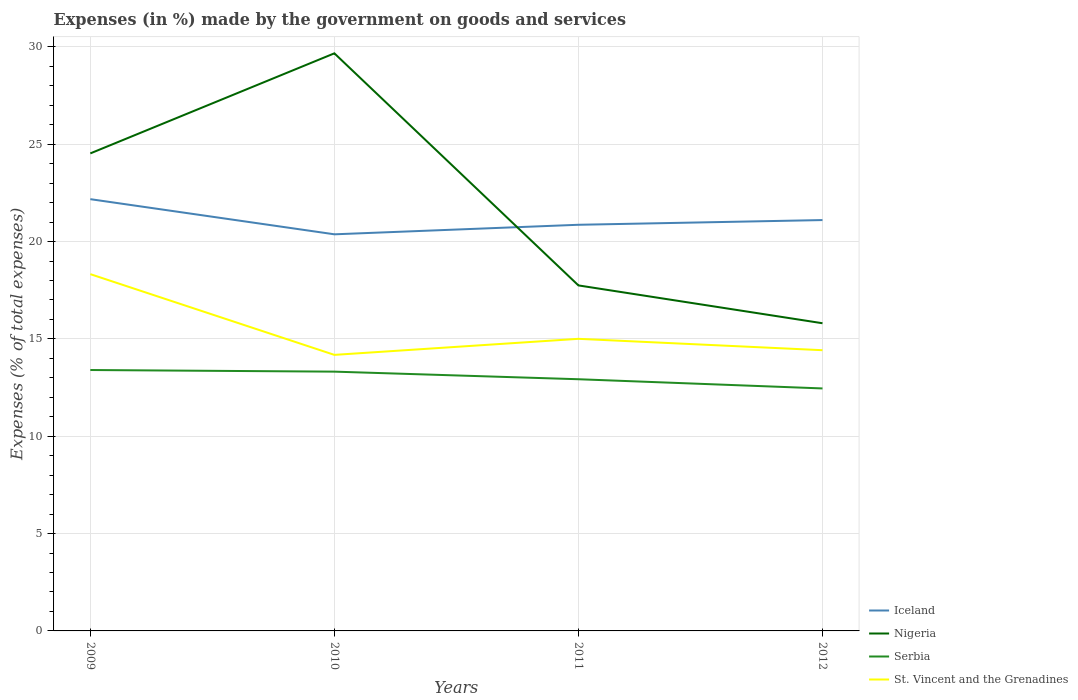Does the line corresponding to St. Vincent and the Grenadines intersect with the line corresponding to Iceland?
Provide a short and direct response. No. Is the number of lines equal to the number of legend labels?
Your answer should be compact. Yes. Across all years, what is the maximum percentage of expenses made by the government on goods and services in Nigeria?
Offer a terse response. 15.8. In which year was the percentage of expenses made by the government on goods and services in Serbia maximum?
Provide a succinct answer. 2012. What is the total percentage of expenses made by the government on goods and services in Nigeria in the graph?
Keep it short and to the point. 8.72. What is the difference between the highest and the second highest percentage of expenses made by the government on goods and services in Serbia?
Your answer should be compact. 0.95. Is the percentage of expenses made by the government on goods and services in St. Vincent and the Grenadines strictly greater than the percentage of expenses made by the government on goods and services in Iceland over the years?
Ensure brevity in your answer.  Yes. How many lines are there?
Your answer should be very brief. 4. How many years are there in the graph?
Ensure brevity in your answer.  4. Does the graph contain any zero values?
Make the answer very short. No. Does the graph contain grids?
Offer a very short reply. Yes. How many legend labels are there?
Provide a short and direct response. 4. What is the title of the graph?
Your response must be concise. Expenses (in %) made by the government on goods and services. What is the label or title of the Y-axis?
Offer a terse response. Expenses (% of total expenses). What is the Expenses (% of total expenses) of Iceland in 2009?
Ensure brevity in your answer.  22.18. What is the Expenses (% of total expenses) in Nigeria in 2009?
Ensure brevity in your answer.  24.53. What is the Expenses (% of total expenses) in Serbia in 2009?
Make the answer very short. 13.4. What is the Expenses (% of total expenses) of St. Vincent and the Grenadines in 2009?
Provide a short and direct response. 18.33. What is the Expenses (% of total expenses) of Iceland in 2010?
Give a very brief answer. 20.37. What is the Expenses (% of total expenses) in Nigeria in 2010?
Keep it short and to the point. 29.67. What is the Expenses (% of total expenses) in Serbia in 2010?
Your answer should be compact. 13.32. What is the Expenses (% of total expenses) in St. Vincent and the Grenadines in 2010?
Make the answer very short. 14.18. What is the Expenses (% of total expenses) of Iceland in 2011?
Ensure brevity in your answer.  20.86. What is the Expenses (% of total expenses) in Nigeria in 2011?
Give a very brief answer. 17.75. What is the Expenses (% of total expenses) of Serbia in 2011?
Ensure brevity in your answer.  12.93. What is the Expenses (% of total expenses) of St. Vincent and the Grenadines in 2011?
Ensure brevity in your answer.  15. What is the Expenses (% of total expenses) of Iceland in 2012?
Ensure brevity in your answer.  21.11. What is the Expenses (% of total expenses) of Nigeria in 2012?
Provide a succinct answer. 15.8. What is the Expenses (% of total expenses) of Serbia in 2012?
Offer a terse response. 12.46. What is the Expenses (% of total expenses) of St. Vincent and the Grenadines in 2012?
Give a very brief answer. 14.42. Across all years, what is the maximum Expenses (% of total expenses) of Iceland?
Offer a very short reply. 22.18. Across all years, what is the maximum Expenses (% of total expenses) in Nigeria?
Make the answer very short. 29.67. Across all years, what is the maximum Expenses (% of total expenses) in Serbia?
Your answer should be compact. 13.4. Across all years, what is the maximum Expenses (% of total expenses) of St. Vincent and the Grenadines?
Offer a terse response. 18.33. Across all years, what is the minimum Expenses (% of total expenses) of Iceland?
Your answer should be compact. 20.37. Across all years, what is the minimum Expenses (% of total expenses) of Nigeria?
Your response must be concise. 15.8. Across all years, what is the minimum Expenses (% of total expenses) of Serbia?
Ensure brevity in your answer.  12.46. Across all years, what is the minimum Expenses (% of total expenses) of St. Vincent and the Grenadines?
Your answer should be compact. 14.18. What is the total Expenses (% of total expenses) in Iceland in the graph?
Your response must be concise. 84.52. What is the total Expenses (% of total expenses) of Nigeria in the graph?
Offer a terse response. 87.75. What is the total Expenses (% of total expenses) in Serbia in the graph?
Offer a terse response. 52.1. What is the total Expenses (% of total expenses) in St. Vincent and the Grenadines in the graph?
Your answer should be very brief. 61.93. What is the difference between the Expenses (% of total expenses) of Iceland in 2009 and that in 2010?
Keep it short and to the point. 1.8. What is the difference between the Expenses (% of total expenses) of Nigeria in 2009 and that in 2010?
Give a very brief answer. -5.14. What is the difference between the Expenses (% of total expenses) in Serbia in 2009 and that in 2010?
Provide a succinct answer. 0.08. What is the difference between the Expenses (% of total expenses) of St. Vincent and the Grenadines in 2009 and that in 2010?
Offer a very short reply. 4.15. What is the difference between the Expenses (% of total expenses) in Iceland in 2009 and that in 2011?
Offer a very short reply. 1.32. What is the difference between the Expenses (% of total expenses) in Nigeria in 2009 and that in 2011?
Provide a succinct answer. 6.78. What is the difference between the Expenses (% of total expenses) of Serbia in 2009 and that in 2011?
Your answer should be very brief. 0.47. What is the difference between the Expenses (% of total expenses) of St. Vincent and the Grenadines in 2009 and that in 2011?
Offer a terse response. 3.32. What is the difference between the Expenses (% of total expenses) in Iceland in 2009 and that in 2012?
Make the answer very short. 1.07. What is the difference between the Expenses (% of total expenses) in Nigeria in 2009 and that in 2012?
Give a very brief answer. 8.72. What is the difference between the Expenses (% of total expenses) in Serbia in 2009 and that in 2012?
Provide a succinct answer. 0.95. What is the difference between the Expenses (% of total expenses) in St. Vincent and the Grenadines in 2009 and that in 2012?
Ensure brevity in your answer.  3.91. What is the difference between the Expenses (% of total expenses) in Iceland in 2010 and that in 2011?
Ensure brevity in your answer.  -0.49. What is the difference between the Expenses (% of total expenses) of Nigeria in 2010 and that in 2011?
Make the answer very short. 11.92. What is the difference between the Expenses (% of total expenses) in Serbia in 2010 and that in 2011?
Provide a succinct answer. 0.39. What is the difference between the Expenses (% of total expenses) of St. Vincent and the Grenadines in 2010 and that in 2011?
Ensure brevity in your answer.  -0.82. What is the difference between the Expenses (% of total expenses) in Iceland in 2010 and that in 2012?
Offer a very short reply. -0.73. What is the difference between the Expenses (% of total expenses) of Nigeria in 2010 and that in 2012?
Your response must be concise. 13.86. What is the difference between the Expenses (% of total expenses) in Serbia in 2010 and that in 2012?
Your response must be concise. 0.86. What is the difference between the Expenses (% of total expenses) of St. Vincent and the Grenadines in 2010 and that in 2012?
Keep it short and to the point. -0.24. What is the difference between the Expenses (% of total expenses) of Iceland in 2011 and that in 2012?
Give a very brief answer. -0.24. What is the difference between the Expenses (% of total expenses) of Nigeria in 2011 and that in 2012?
Provide a succinct answer. 1.94. What is the difference between the Expenses (% of total expenses) in Serbia in 2011 and that in 2012?
Give a very brief answer. 0.47. What is the difference between the Expenses (% of total expenses) in St. Vincent and the Grenadines in 2011 and that in 2012?
Your answer should be compact. 0.58. What is the difference between the Expenses (% of total expenses) of Iceland in 2009 and the Expenses (% of total expenses) of Nigeria in 2010?
Ensure brevity in your answer.  -7.49. What is the difference between the Expenses (% of total expenses) in Iceland in 2009 and the Expenses (% of total expenses) in Serbia in 2010?
Your answer should be very brief. 8.86. What is the difference between the Expenses (% of total expenses) in Iceland in 2009 and the Expenses (% of total expenses) in St. Vincent and the Grenadines in 2010?
Give a very brief answer. 8. What is the difference between the Expenses (% of total expenses) in Nigeria in 2009 and the Expenses (% of total expenses) in Serbia in 2010?
Offer a terse response. 11.21. What is the difference between the Expenses (% of total expenses) of Nigeria in 2009 and the Expenses (% of total expenses) of St. Vincent and the Grenadines in 2010?
Ensure brevity in your answer.  10.35. What is the difference between the Expenses (% of total expenses) of Serbia in 2009 and the Expenses (% of total expenses) of St. Vincent and the Grenadines in 2010?
Your answer should be compact. -0.78. What is the difference between the Expenses (% of total expenses) of Iceland in 2009 and the Expenses (% of total expenses) of Nigeria in 2011?
Your answer should be compact. 4.43. What is the difference between the Expenses (% of total expenses) of Iceland in 2009 and the Expenses (% of total expenses) of Serbia in 2011?
Your response must be concise. 9.25. What is the difference between the Expenses (% of total expenses) in Iceland in 2009 and the Expenses (% of total expenses) in St. Vincent and the Grenadines in 2011?
Give a very brief answer. 7.17. What is the difference between the Expenses (% of total expenses) in Nigeria in 2009 and the Expenses (% of total expenses) in Serbia in 2011?
Offer a terse response. 11.6. What is the difference between the Expenses (% of total expenses) of Nigeria in 2009 and the Expenses (% of total expenses) of St. Vincent and the Grenadines in 2011?
Provide a short and direct response. 9.53. What is the difference between the Expenses (% of total expenses) in Serbia in 2009 and the Expenses (% of total expenses) in St. Vincent and the Grenadines in 2011?
Provide a short and direct response. -1.6. What is the difference between the Expenses (% of total expenses) in Iceland in 2009 and the Expenses (% of total expenses) in Nigeria in 2012?
Your response must be concise. 6.37. What is the difference between the Expenses (% of total expenses) of Iceland in 2009 and the Expenses (% of total expenses) of Serbia in 2012?
Provide a short and direct response. 9.72. What is the difference between the Expenses (% of total expenses) of Iceland in 2009 and the Expenses (% of total expenses) of St. Vincent and the Grenadines in 2012?
Make the answer very short. 7.76. What is the difference between the Expenses (% of total expenses) in Nigeria in 2009 and the Expenses (% of total expenses) in Serbia in 2012?
Provide a succinct answer. 12.07. What is the difference between the Expenses (% of total expenses) of Nigeria in 2009 and the Expenses (% of total expenses) of St. Vincent and the Grenadines in 2012?
Offer a terse response. 10.11. What is the difference between the Expenses (% of total expenses) in Serbia in 2009 and the Expenses (% of total expenses) in St. Vincent and the Grenadines in 2012?
Ensure brevity in your answer.  -1.02. What is the difference between the Expenses (% of total expenses) of Iceland in 2010 and the Expenses (% of total expenses) of Nigeria in 2011?
Your answer should be very brief. 2.63. What is the difference between the Expenses (% of total expenses) in Iceland in 2010 and the Expenses (% of total expenses) in Serbia in 2011?
Your answer should be very brief. 7.44. What is the difference between the Expenses (% of total expenses) in Iceland in 2010 and the Expenses (% of total expenses) in St. Vincent and the Grenadines in 2011?
Keep it short and to the point. 5.37. What is the difference between the Expenses (% of total expenses) in Nigeria in 2010 and the Expenses (% of total expenses) in Serbia in 2011?
Ensure brevity in your answer.  16.74. What is the difference between the Expenses (% of total expenses) in Nigeria in 2010 and the Expenses (% of total expenses) in St. Vincent and the Grenadines in 2011?
Make the answer very short. 14.67. What is the difference between the Expenses (% of total expenses) in Serbia in 2010 and the Expenses (% of total expenses) in St. Vincent and the Grenadines in 2011?
Your answer should be compact. -1.69. What is the difference between the Expenses (% of total expenses) in Iceland in 2010 and the Expenses (% of total expenses) in Nigeria in 2012?
Offer a terse response. 4.57. What is the difference between the Expenses (% of total expenses) in Iceland in 2010 and the Expenses (% of total expenses) in Serbia in 2012?
Keep it short and to the point. 7.92. What is the difference between the Expenses (% of total expenses) in Iceland in 2010 and the Expenses (% of total expenses) in St. Vincent and the Grenadines in 2012?
Keep it short and to the point. 5.95. What is the difference between the Expenses (% of total expenses) of Nigeria in 2010 and the Expenses (% of total expenses) of Serbia in 2012?
Give a very brief answer. 17.21. What is the difference between the Expenses (% of total expenses) in Nigeria in 2010 and the Expenses (% of total expenses) in St. Vincent and the Grenadines in 2012?
Your answer should be compact. 15.25. What is the difference between the Expenses (% of total expenses) in Serbia in 2010 and the Expenses (% of total expenses) in St. Vincent and the Grenadines in 2012?
Offer a very short reply. -1.1. What is the difference between the Expenses (% of total expenses) in Iceland in 2011 and the Expenses (% of total expenses) in Nigeria in 2012?
Offer a terse response. 5.06. What is the difference between the Expenses (% of total expenses) of Iceland in 2011 and the Expenses (% of total expenses) of Serbia in 2012?
Provide a short and direct response. 8.41. What is the difference between the Expenses (% of total expenses) of Iceland in 2011 and the Expenses (% of total expenses) of St. Vincent and the Grenadines in 2012?
Give a very brief answer. 6.44. What is the difference between the Expenses (% of total expenses) of Nigeria in 2011 and the Expenses (% of total expenses) of Serbia in 2012?
Your response must be concise. 5.29. What is the difference between the Expenses (% of total expenses) in Nigeria in 2011 and the Expenses (% of total expenses) in St. Vincent and the Grenadines in 2012?
Keep it short and to the point. 3.33. What is the difference between the Expenses (% of total expenses) of Serbia in 2011 and the Expenses (% of total expenses) of St. Vincent and the Grenadines in 2012?
Your response must be concise. -1.49. What is the average Expenses (% of total expenses) of Iceland per year?
Give a very brief answer. 21.13. What is the average Expenses (% of total expenses) in Nigeria per year?
Provide a short and direct response. 21.94. What is the average Expenses (% of total expenses) in Serbia per year?
Your answer should be compact. 13.03. What is the average Expenses (% of total expenses) of St. Vincent and the Grenadines per year?
Your answer should be very brief. 15.48. In the year 2009, what is the difference between the Expenses (% of total expenses) of Iceland and Expenses (% of total expenses) of Nigeria?
Provide a short and direct response. -2.35. In the year 2009, what is the difference between the Expenses (% of total expenses) in Iceland and Expenses (% of total expenses) in Serbia?
Offer a terse response. 8.78. In the year 2009, what is the difference between the Expenses (% of total expenses) of Iceland and Expenses (% of total expenses) of St. Vincent and the Grenadines?
Your response must be concise. 3.85. In the year 2009, what is the difference between the Expenses (% of total expenses) in Nigeria and Expenses (% of total expenses) in Serbia?
Your answer should be very brief. 11.13. In the year 2009, what is the difference between the Expenses (% of total expenses) in Nigeria and Expenses (% of total expenses) in St. Vincent and the Grenadines?
Provide a succinct answer. 6.2. In the year 2009, what is the difference between the Expenses (% of total expenses) in Serbia and Expenses (% of total expenses) in St. Vincent and the Grenadines?
Give a very brief answer. -4.92. In the year 2010, what is the difference between the Expenses (% of total expenses) of Iceland and Expenses (% of total expenses) of Nigeria?
Your response must be concise. -9.3. In the year 2010, what is the difference between the Expenses (% of total expenses) of Iceland and Expenses (% of total expenses) of Serbia?
Keep it short and to the point. 7.05. In the year 2010, what is the difference between the Expenses (% of total expenses) of Iceland and Expenses (% of total expenses) of St. Vincent and the Grenadines?
Provide a short and direct response. 6.19. In the year 2010, what is the difference between the Expenses (% of total expenses) of Nigeria and Expenses (% of total expenses) of Serbia?
Keep it short and to the point. 16.35. In the year 2010, what is the difference between the Expenses (% of total expenses) in Nigeria and Expenses (% of total expenses) in St. Vincent and the Grenadines?
Make the answer very short. 15.49. In the year 2010, what is the difference between the Expenses (% of total expenses) in Serbia and Expenses (% of total expenses) in St. Vincent and the Grenadines?
Ensure brevity in your answer.  -0.86. In the year 2011, what is the difference between the Expenses (% of total expenses) of Iceland and Expenses (% of total expenses) of Nigeria?
Your answer should be compact. 3.12. In the year 2011, what is the difference between the Expenses (% of total expenses) in Iceland and Expenses (% of total expenses) in Serbia?
Ensure brevity in your answer.  7.93. In the year 2011, what is the difference between the Expenses (% of total expenses) in Iceland and Expenses (% of total expenses) in St. Vincent and the Grenadines?
Your answer should be very brief. 5.86. In the year 2011, what is the difference between the Expenses (% of total expenses) in Nigeria and Expenses (% of total expenses) in Serbia?
Your answer should be compact. 4.82. In the year 2011, what is the difference between the Expenses (% of total expenses) of Nigeria and Expenses (% of total expenses) of St. Vincent and the Grenadines?
Keep it short and to the point. 2.74. In the year 2011, what is the difference between the Expenses (% of total expenses) of Serbia and Expenses (% of total expenses) of St. Vincent and the Grenadines?
Your answer should be very brief. -2.08. In the year 2012, what is the difference between the Expenses (% of total expenses) in Iceland and Expenses (% of total expenses) in Nigeria?
Give a very brief answer. 5.3. In the year 2012, what is the difference between the Expenses (% of total expenses) of Iceland and Expenses (% of total expenses) of Serbia?
Provide a short and direct response. 8.65. In the year 2012, what is the difference between the Expenses (% of total expenses) in Iceland and Expenses (% of total expenses) in St. Vincent and the Grenadines?
Offer a very short reply. 6.69. In the year 2012, what is the difference between the Expenses (% of total expenses) of Nigeria and Expenses (% of total expenses) of Serbia?
Ensure brevity in your answer.  3.35. In the year 2012, what is the difference between the Expenses (% of total expenses) in Nigeria and Expenses (% of total expenses) in St. Vincent and the Grenadines?
Provide a short and direct response. 1.38. In the year 2012, what is the difference between the Expenses (% of total expenses) of Serbia and Expenses (% of total expenses) of St. Vincent and the Grenadines?
Provide a short and direct response. -1.96. What is the ratio of the Expenses (% of total expenses) of Iceland in 2009 to that in 2010?
Give a very brief answer. 1.09. What is the ratio of the Expenses (% of total expenses) in Nigeria in 2009 to that in 2010?
Keep it short and to the point. 0.83. What is the ratio of the Expenses (% of total expenses) in Serbia in 2009 to that in 2010?
Provide a short and direct response. 1.01. What is the ratio of the Expenses (% of total expenses) of St. Vincent and the Grenadines in 2009 to that in 2010?
Your answer should be very brief. 1.29. What is the ratio of the Expenses (% of total expenses) of Iceland in 2009 to that in 2011?
Offer a very short reply. 1.06. What is the ratio of the Expenses (% of total expenses) of Nigeria in 2009 to that in 2011?
Your answer should be compact. 1.38. What is the ratio of the Expenses (% of total expenses) in Serbia in 2009 to that in 2011?
Ensure brevity in your answer.  1.04. What is the ratio of the Expenses (% of total expenses) of St. Vincent and the Grenadines in 2009 to that in 2011?
Your response must be concise. 1.22. What is the ratio of the Expenses (% of total expenses) in Iceland in 2009 to that in 2012?
Ensure brevity in your answer.  1.05. What is the ratio of the Expenses (% of total expenses) of Nigeria in 2009 to that in 2012?
Keep it short and to the point. 1.55. What is the ratio of the Expenses (% of total expenses) in Serbia in 2009 to that in 2012?
Your answer should be compact. 1.08. What is the ratio of the Expenses (% of total expenses) of St. Vincent and the Grenadines in 2009 to that in 2012?
Make the answer very short. 1.27. What is the ratio of the Expenses (% of total expenses) in Iceland in 2010 to that in 2011?
Your answer should be very brief. 0.98. What is the ratio of the Expenses (% of total expenses) in Nigeria in 2010 to that in 2011?
Make the answer very short. 1.67. What is the ratio of the Expenses (% of total expenses) in Serbia in 2010 to that in 2011?
Your response must be concise. 1.03. What is the ratio of the Expenses (% of total expenses) in St. Vincent and the Grenadines in 2010 to that in 2011?
Keep it short and to the point. 0.95. What is the ratio of the Expenses (% of total expenses) in Iceland in 2010 to that in 2012?
Offer a very short reply. 0.97. What is the ratio of the Expenses (% of total expenses) of Nigeria in 2010 to that in 2012?
Your answer should be compact. 1.88. What is the ratio of the Expenses (% of total expenses) in Serbia in 2010 to that in 2012?
Make the answer very short. 1.07. What is the ratio of the Expenses (% of total expenses) of St. Vincent and the Grenadines in 2010 to that in 2012?
Make the answer very short. 0.98. What is the ratio of the Expenses (% of total expenses) in Nigeria in 2011 to that in 2012?
Your response must be concise. 1.12. What is the ratio of the Expenses (% of total expenses) in Serbia in 2011 to that in 2012?
Make the answer very short. 1.04. What is the ratio of the Expenses (% of total expenses) in St. Vincent and the Grenadines in 2011 to that in 2012?
Ensure brevity in your answer.  1.04. What is the difference between the highest and the second highest Expenses (% of total expenses) in Iceland?
Your answer should be compact. 1.07. What is the difference between the highest and the second highest Expenses (% of total expenses) in Nigeria?
Ensure brevity in your answer.  5.14. What is the difference between the highest and the second highest Expenses (% of total expenses) in Serbia?
Your answer should be compact. 0.08. What is the difference between the highest and the second highest Expenses (% of total expenses) of St. Vincent and the Grenadines?
Offer a very short reply. 3.32. What is the difference between the highest and the lowest Expenses (% of total expenses) in Iceland?
Your answer should be compact. 1.8. What is the difference between the highest and the lowest Expenses (% of total expenses) in Nigeria?
Give a very brief answer. 13.86. What is the difference between the highest and the lowest Expenses (% of total expenses) of Serbia?
Your response must be concise. 0.95. What is the difference between the highest and the lowest Expenses (% of total expenses) of St. Vincent and the Grenadines?
Offer a very short reply. 4.15. 